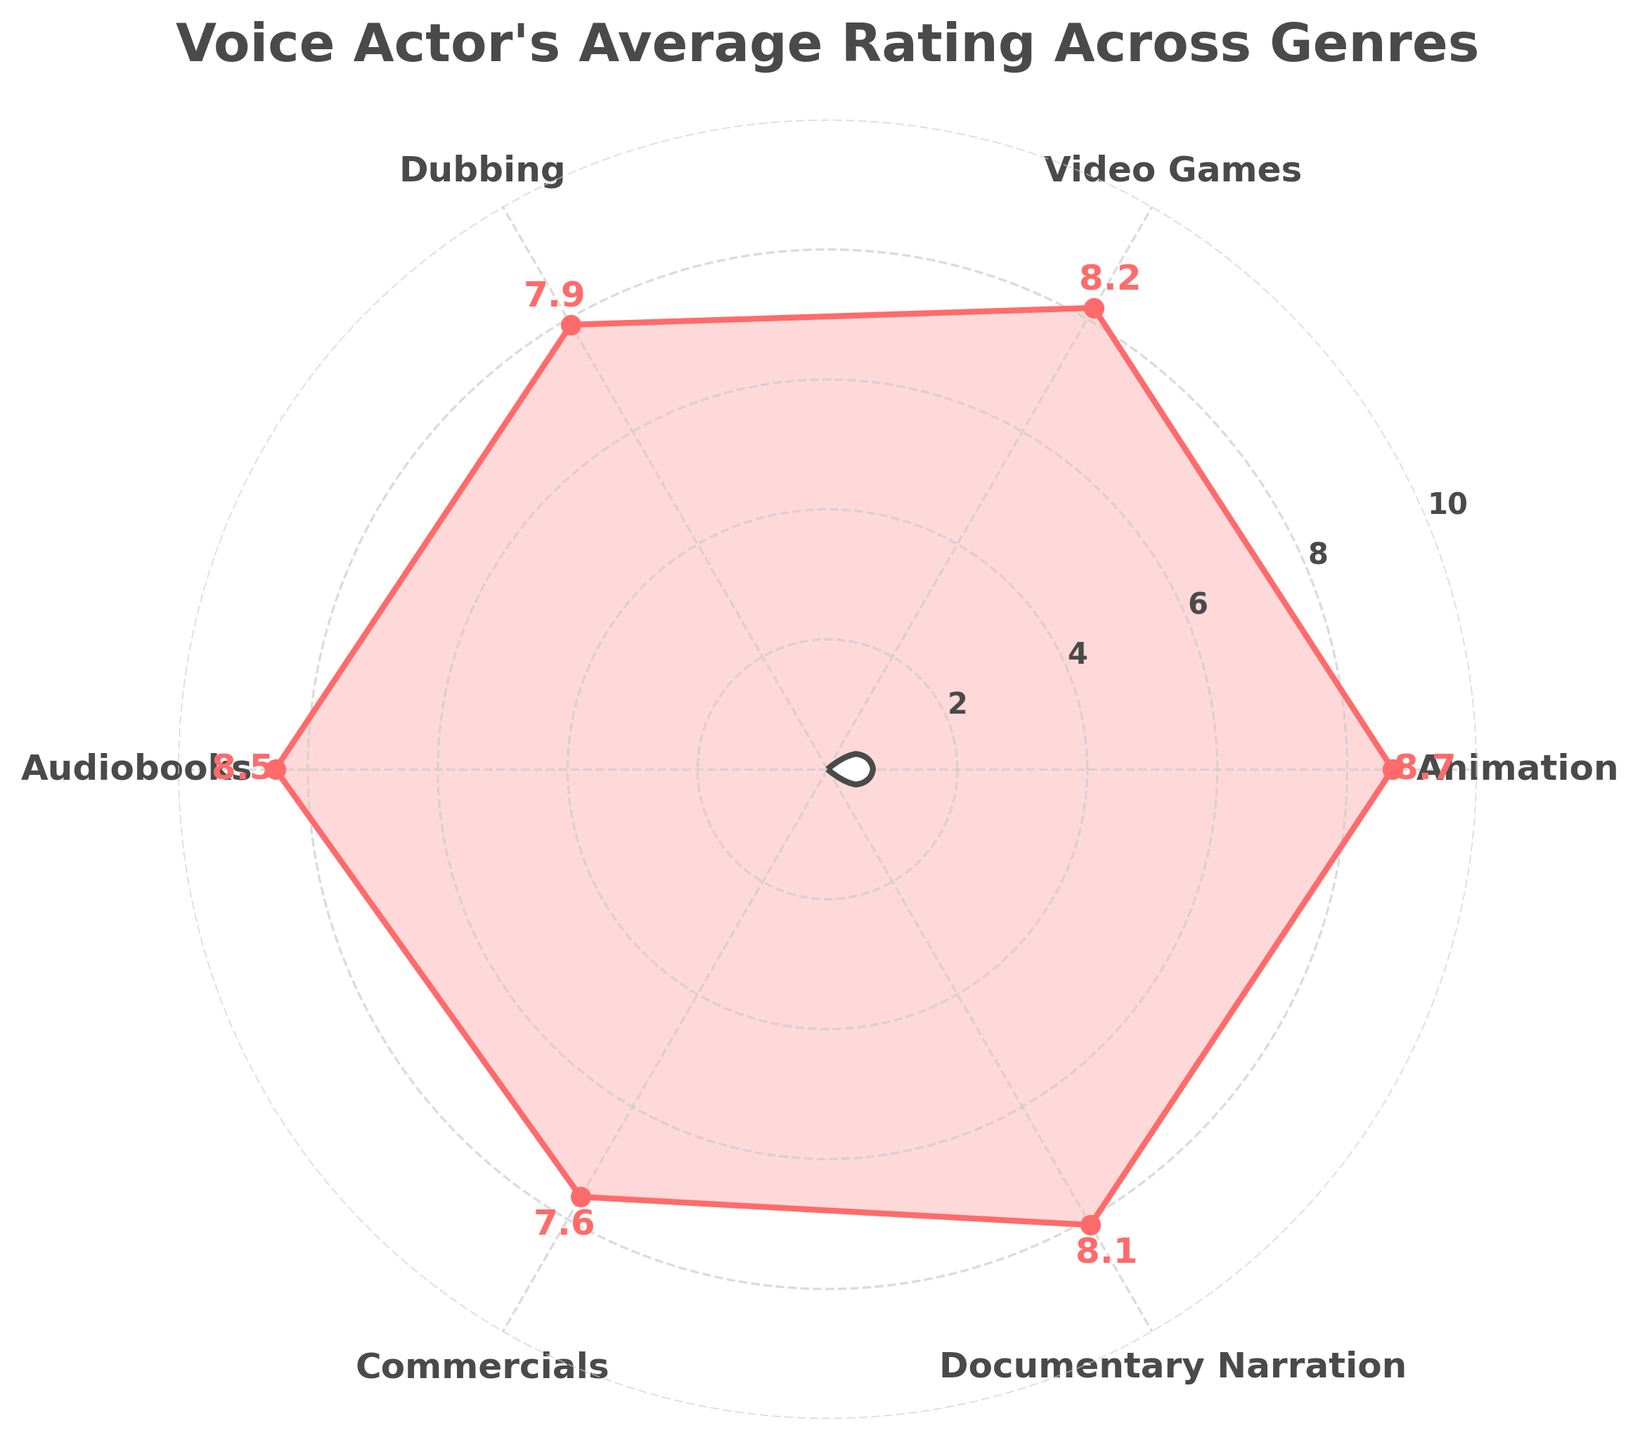What is the title of the figure? The title of the figure is located at the top and provides a summary of what the chart is about.
Answer: Voice Actor's Average Rating Across Genres How many genres are represented in the figure? Count the number of distinct labels around the circumference of the polar plot.
Answer: 6 Which genre has the highest average rating? Identify the point on the chart that extends furthest from the center.
Answer: Animation What is the average rating for Commercials? Locate the label "Commercials" around the chart and follow the corresponding line to read the value.
Answer: 7.6 What is the difference between the highest and lowest average ratings? Find the highest and lowest points on the chart and subtract the lowest value from the highest value.
Answer: 8.7 - 7.6 = 1.1 Which two genres have the closest average ratings? Compare the ratings of each genre and identify the two with the minimal difference between them.
Answer: Video Games and Documentary Narration What is the average rating for Animation and Audiobooks combined? Add the ratings for Animation and Audiobooks, then divide by 2 to find their average.
Answer: (8.7 + 8.5) / 2 = 8.6 How does the average rating for Documentary Narration compare to Dubbing? Locate the ratings for both genres and compare their values.
Answer: Documentary Narration (8.1) is higher than Dubbing (7.9) Which genre has the second highest average rating? Find the highest rating first, and then identify the next highest value on the chart.
Answer: Audiobooks What colors are used in the figure? Observe the different colors used in the plot and list them.
Answer: Red for the plot line and points, grey for the grid lines, white for the center circle 